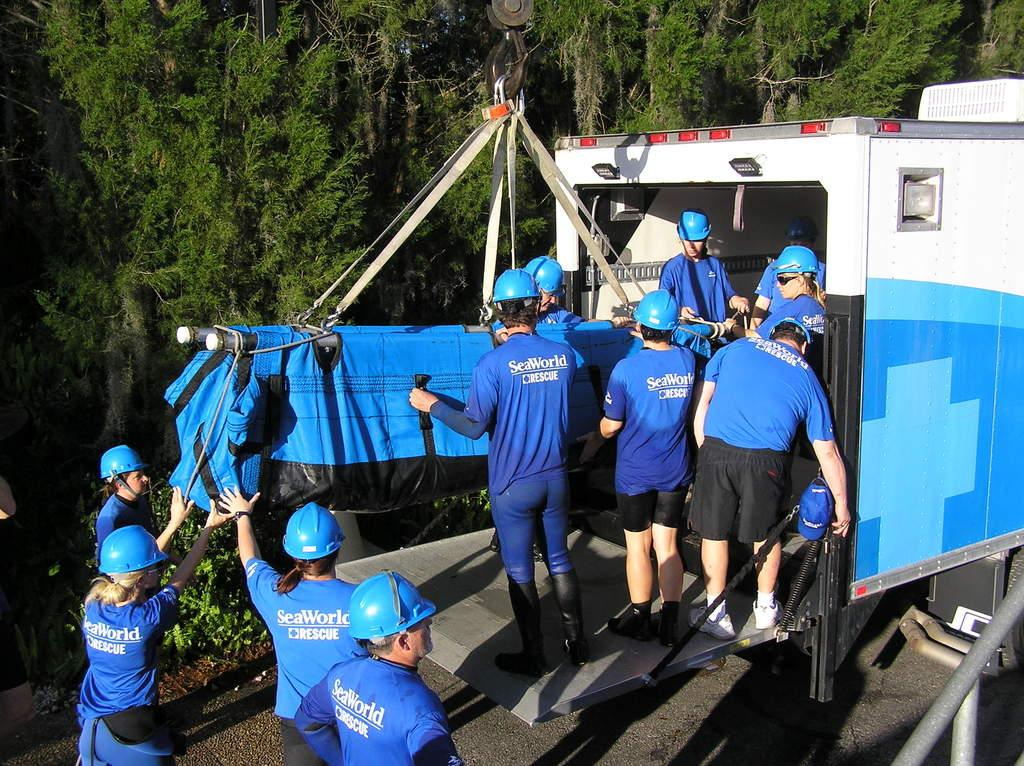What can be seen in the image? There is a group of people in the image. What are the people wearing? The people are wearing blue and black dress and blue helmets. What is located in the center of the image? There is a hanger in the center of the image. What is visible in the background of the image? There are trees in the background of the image. What type of beast can be seen roaming the streets in the image? There is no beast or street present in the image; it features a group of people wearing blue and black dress and blue helmets, a hanger, and trees in the background. 